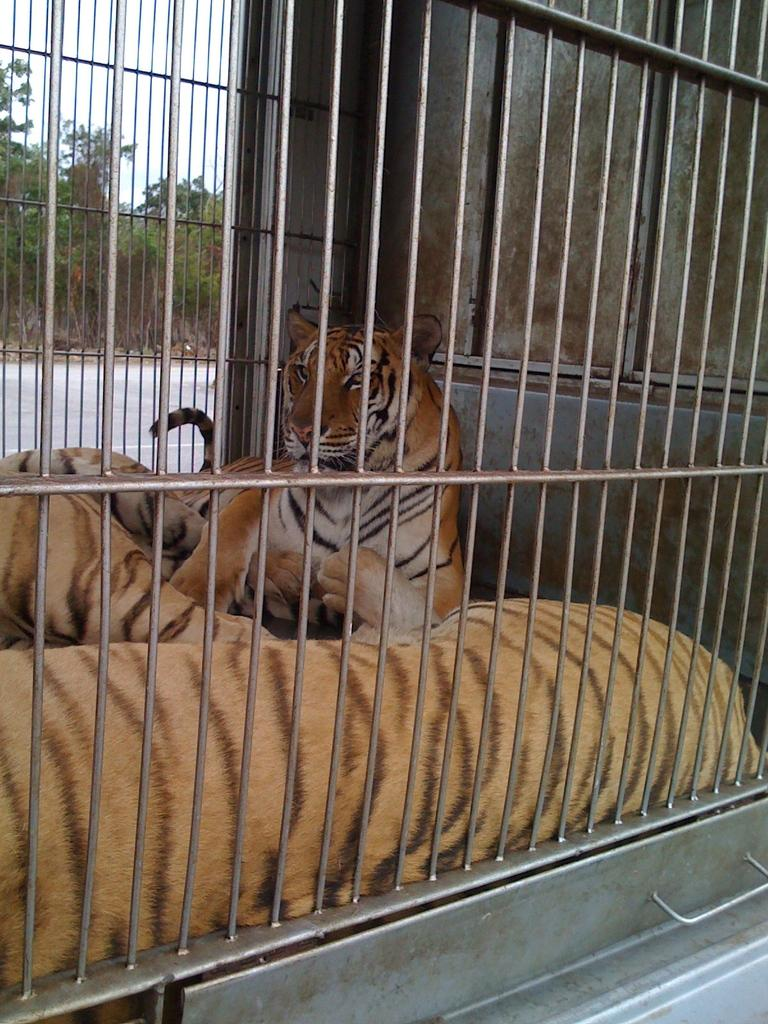What animals are inside the metal cage in the image? There are tigers inside a metal cage in the image. What can be seen on the left side of the image? There is a road and a group of trees on the left side of the image. What is visible in the image besides the animals and the road? The sky is visible in the image. How would you describe the weather based on the appearance of the sky in the image? The sky appears cloudy in the image, suggesting that it might be overcast or possibly rainy. What story is the woman telling the tigers in the image? There is no woman present in the image, so no story can be told to the tigers. How many apples are on the trees in the image? There are no apples visible in the image; only tigers, a metal cage, a road, trees, and the sky are present. 